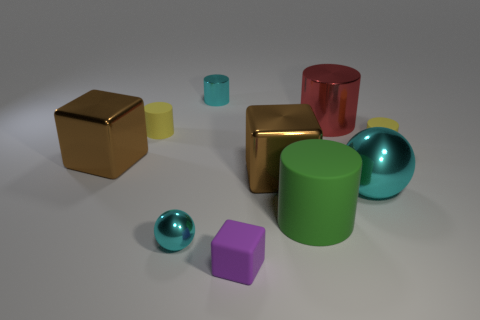There is a big metallic cube to the left of the sphere that is on the left side of the red metallic thing; what is its color?
Your response must be concise. Brown. The small yellow matte object that is on the right side of the small cyan metallic thing in front of the tiny cylinder to the right of the big cyan thing is what shape?
Your response must be concise. Cylinder. There is a cylinder that is in front of the big red metallic cylinder and on the right side of the green matte cylinder; how big is it?
Your answer should be very brief. Small. What number of large balls are the same color as the tiny metallic cylinder?
Keep it short and to the point. 1. What is the material of the small sphere that is the same color as the small metallic cylinder?
Keep it short and to the point. Metal. What is the small block made of?
Provide a succinct answer. Rubber. Is the material of the red cylinder behind the purple block the same as the big ball?
Offer a terse response. Yes. What is the shape of the tiny yellow rubber thing on the right side of the rubber cube?
Keep it short and to the point. Cylinder. What material is the green cylinder that is the same size as the red metal object?
Give a very brief answer. Rubber. What number of objects are small matte objects that are left of the big cyan sphere or cylinders that are left of the large cyan metal sphere?
Your response must be concise. 5. 